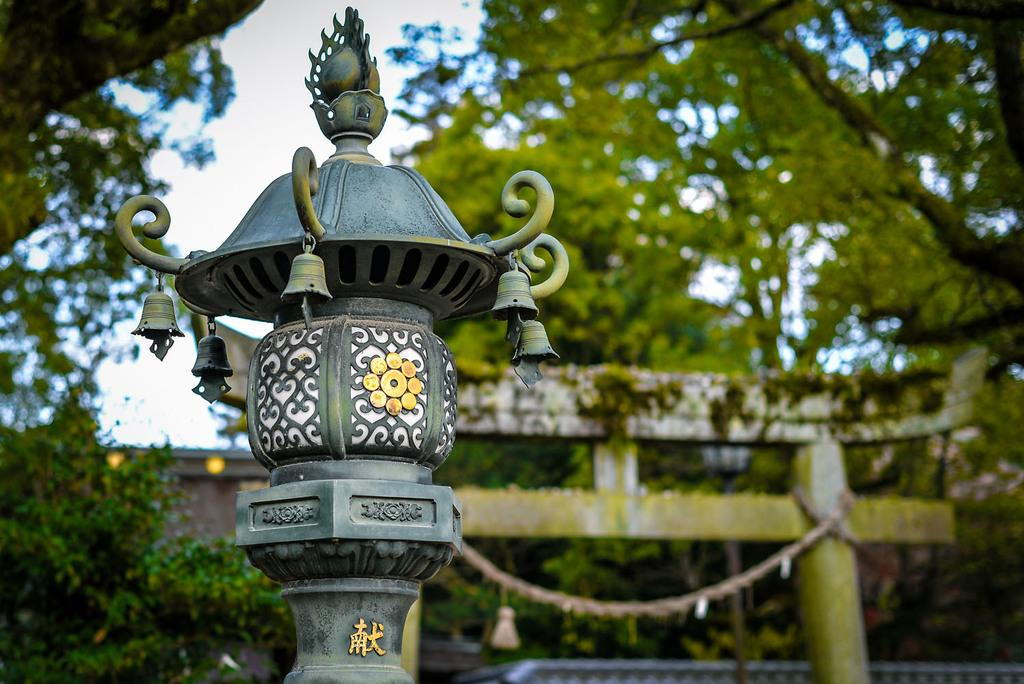What structure is present in the image? There is a lamp post in the image. What can be seen in the background of the image? There are trees and the sky visible in the background of the image. What verse is being recited by the fireman in the image? There is no fireman or verse present in the image. Is the jail visible in the image? There is no jail present in the image. 